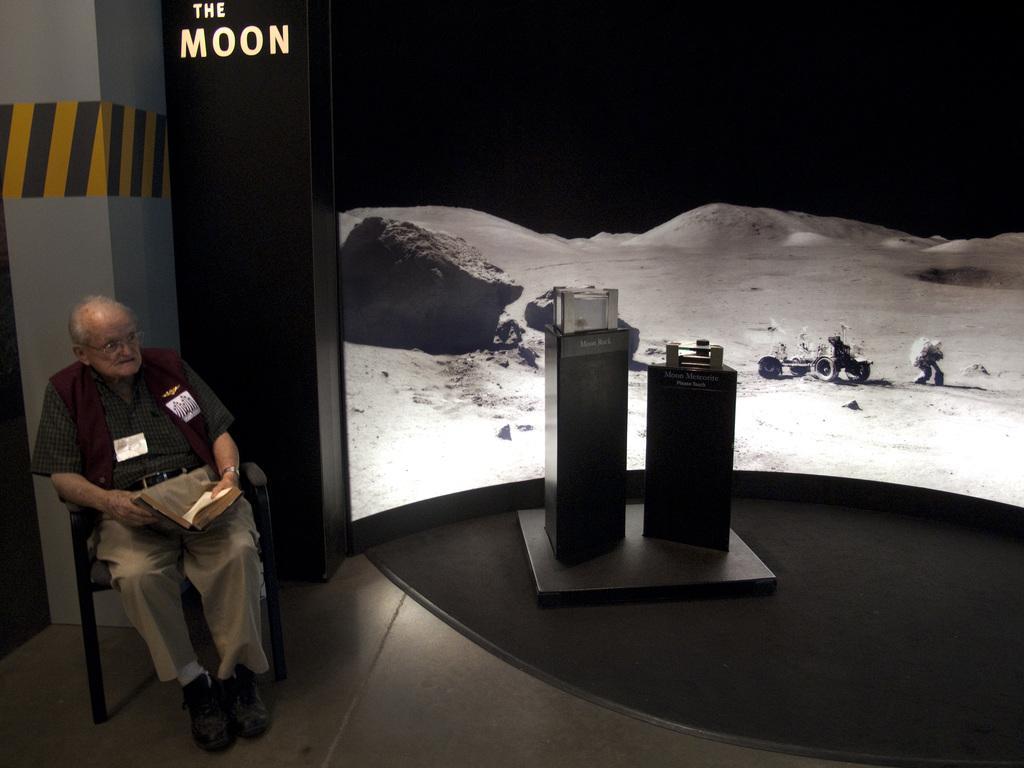Could you give a brief overview of what you see in this image? In this picture there is a man sitting on a chair and holding a book. We can see objects on stands and text on the wall. In the background of the image we can see a screen. 